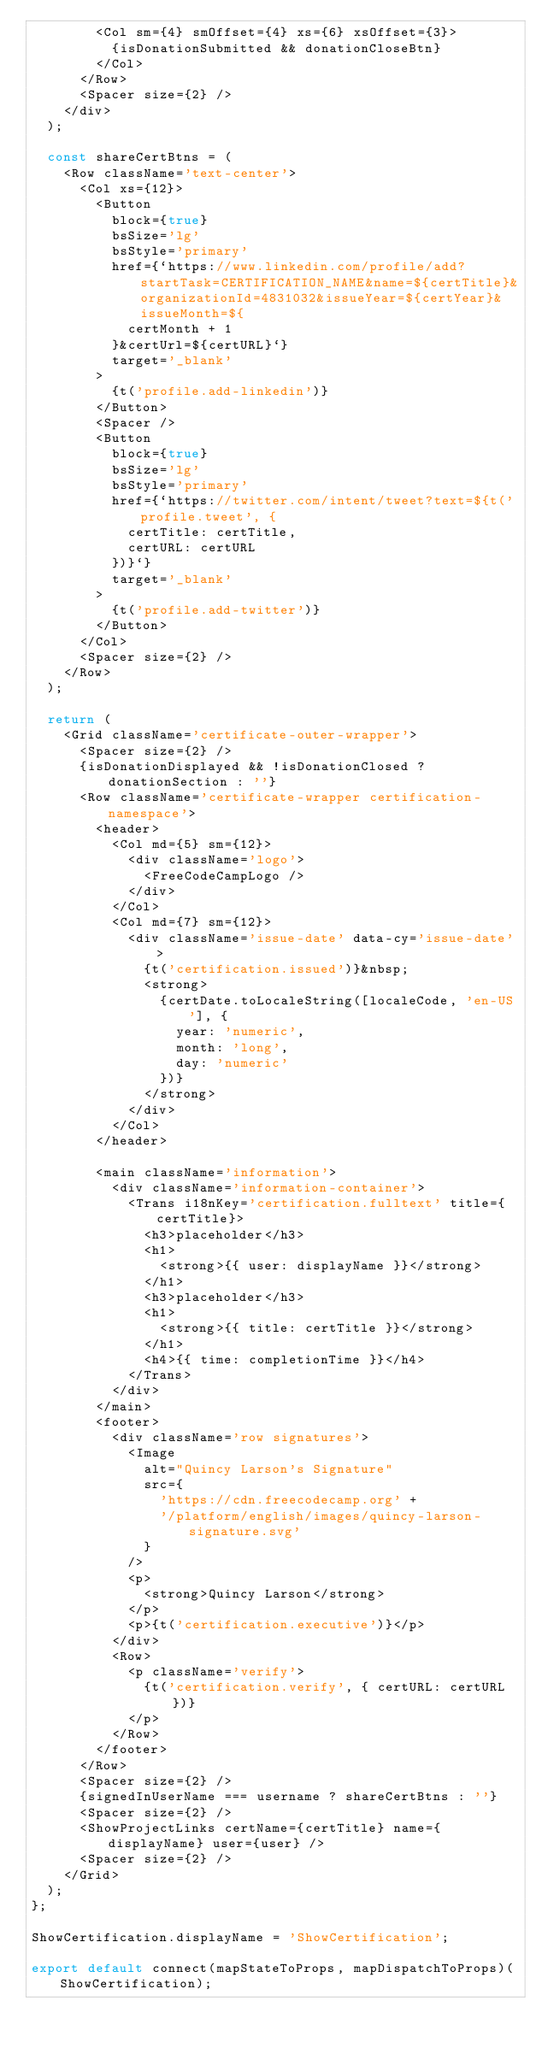<code> <loc_0><loc_0><loc_500><loc_500><_TypeScript_>        <Col sm={4} smOffset={4} xs={6} xsOffset={3}>
          {isDonationSubmitted && donationCloseBtn}
        </Col>
      </Row>
      <Spacer size={2} />
    </div>
  );

  const shareCertBtns = (
    <Row className='text-center'>
      <Col xs={12}>
        <Button
          block={true}
          bsSize='lg'
          bsStyle='primary'
          href={`https://www.linkedin.com/profile/add?startTask=CERTIFICATION_NAME&name=${certTitle}&organizationId=4831032&issueYear=${certYear}&issueMonth=${
            certMonth + 1
          }&certUrl=${certURL}`}
          target='_blank'
        >
          {t('profile.add-linkedin')}
        </Button>
        <Spacer />
        <Button
          block={true}
          bsSize='lg'
          bsStyle='primary'
          href={`https://twitter.com/intent/tweet?text=${t('profile.tweet', {
            certTitle: certTitle,
            certURL: certURL
          })}`}
          target='_blank'
        >
          {t('profile.add-twitter')}
        </Button>
      </Col>
      <Spacer size={2} />
    </Row>
  );

  return (
    <Grid className='certificate-outer-wrapper'>
      <Spacer size={2} />
      {isDonationDisplayed && !isDonationClosed ? donationSection : ''}
      <Row className='certificate-wrapper certification-namespace'>
        <header>
          <Col md={5} sm={12}>
            <div className='logo'>
              <FreeCodeCampLogo />
            </div>
          </Col>
          <Col md={7} sm={12}>
            <div className='issue-date' data-cy='issue-date'>
              {t('certification.issued')}&nbsp;
              <strong>
                {certDate.toLocaleString([localeCode, 'en-US'], {
                  year: 'numeric',
                  month: 'long',
                  day: 'numeric'
                })}
              </strong>
            </div>
          </Col>
        </header>

        <main className='information'>
          <div className='information-container'>
            <Trans i18nKey='certification.fulltext' title={certTitle}>
              <h3>placeholder</h3>
              <h1>
                <strong>{{ user: displayName }}</strong>
              </h1>
              <h3>placeholder</h3>
              <h1>
                <strong>{{ title: certTitle }}</strong>
              </h1>
              <h4>{{ time: completionTime }}</h4>
            </Trans>
          </div>
        </main>
        <footer>
          <div className='row signatures'>
            <Image
              alt="Quincy Larson's Signature"
              src={
                'https://cdn.freecodecamp.org' +
                '/platform/english/images/quincy-larson-signature.svg'
              }
            />
            <p>
              <strong>Quincy Larson</strong>
            </p>
            <p>{t('certification.executive')}</p>
          </div>
          <Row>
            <p className='verify'>
              {t('certification.verify', { certURL: certURL })}
            </p>
          </Row>
        </footer>
      </Row>
      <Spacer size={2} />
      {signedInUserName === username ? shareCertBtns : ''}
      <Spacer size={2} />
      <ShowProjectLinks certName={certTitle} name={displayName} user={user} />
      <Spacer size={2} />
    </Grid>
  );
};

ShowCertification.displayName = 'ShowCertification';

export default connect(mapStateToProps, mapDispatchToProps)(ShowCertification);
</code> 